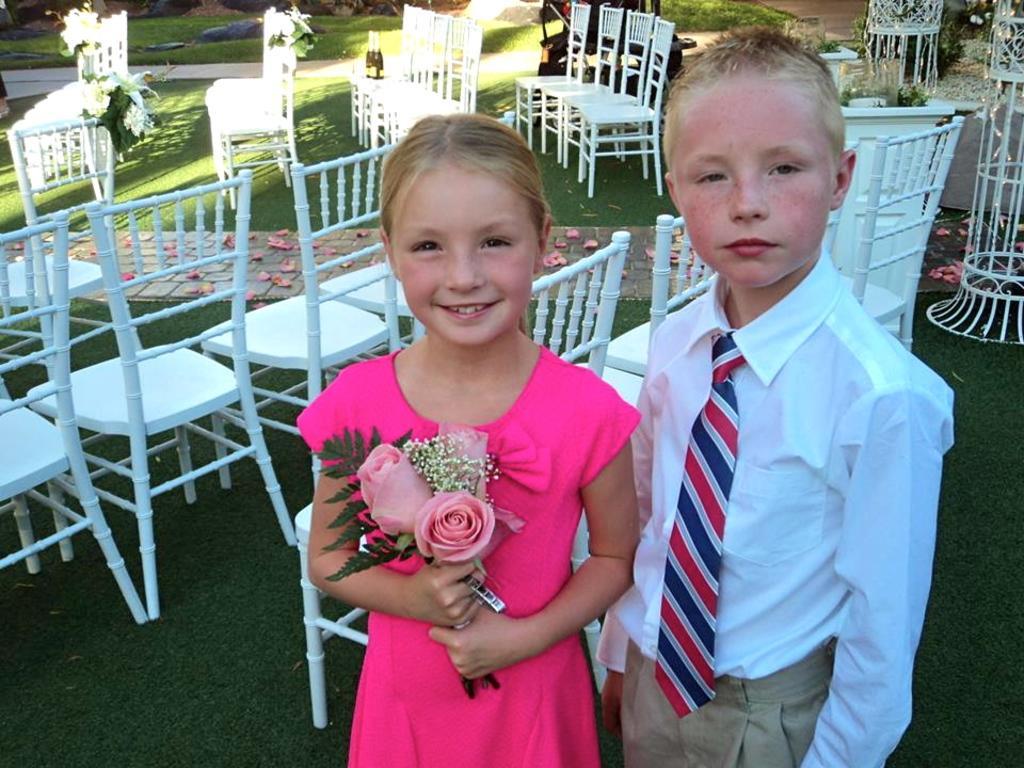Can you describe this image briefly? There is a boy in white color shirt near a girl who is in pink color dress and is smiling, holding flowers and standing. In the background, there are chairs arranged on the grass on the ground, there are flowers on the path, there is another path and there is grass on the ground. 